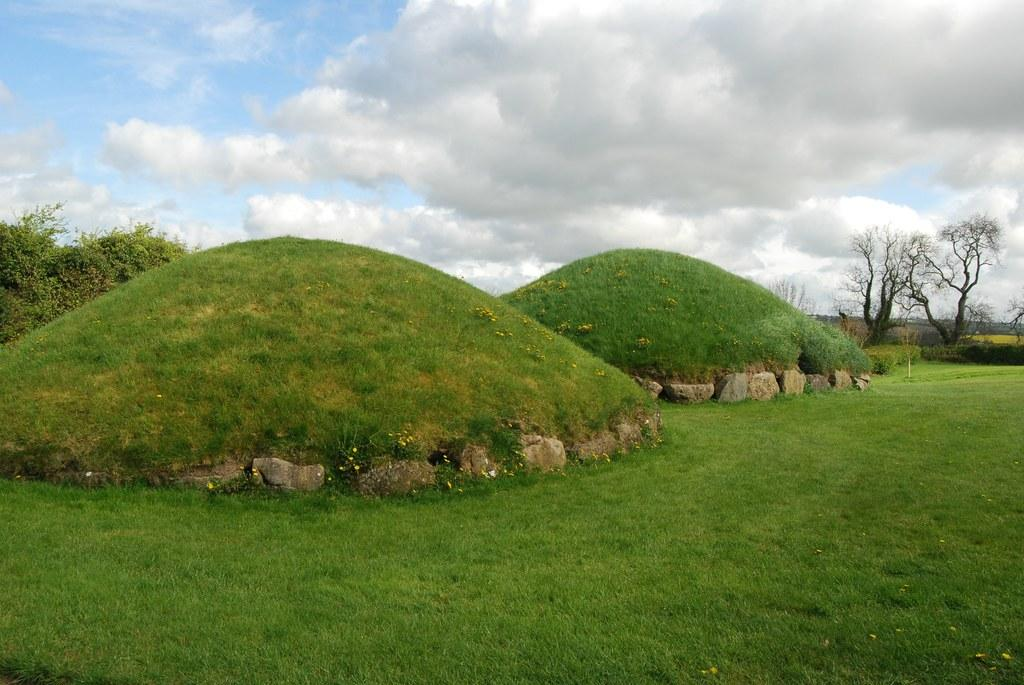What type of ground is visible in the front of the image? There is grass ground in the front of the image. What can be seen in the background of the image? There are trees and clouds visible in the background of the image. What else is visible in the background of the image? The sky is visible in the background of the image. Can you tell me where the grandfather is sitting in the image? There is no grandfather present in the image. What color is the vein in the tree in the image? There is no mention of a vein in the image, as it is a natural part of a tree's structure and not visible to the naked eye. 